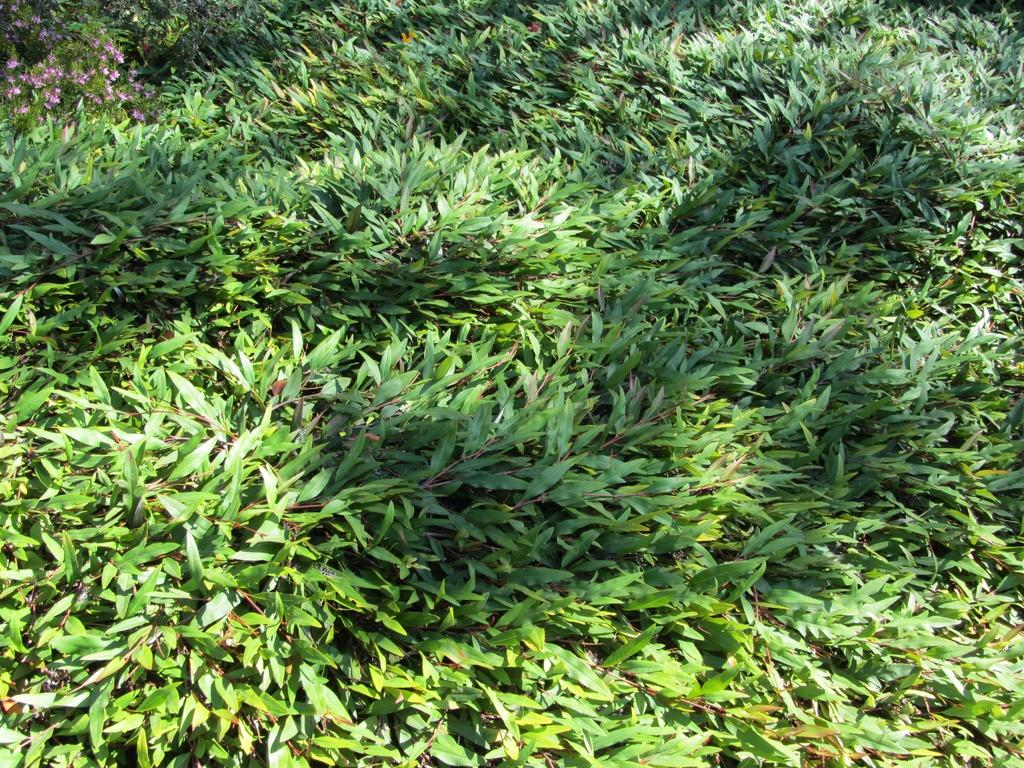What type of vegetation can be seen in the image? There is grass in the image. Where are the flowers located in the image? The flowers are in the top left corner of the image. What type of leather is visible on the police officer's uniform in the image? There are no police officers or leather present in the image; it only features grass and flowers. 